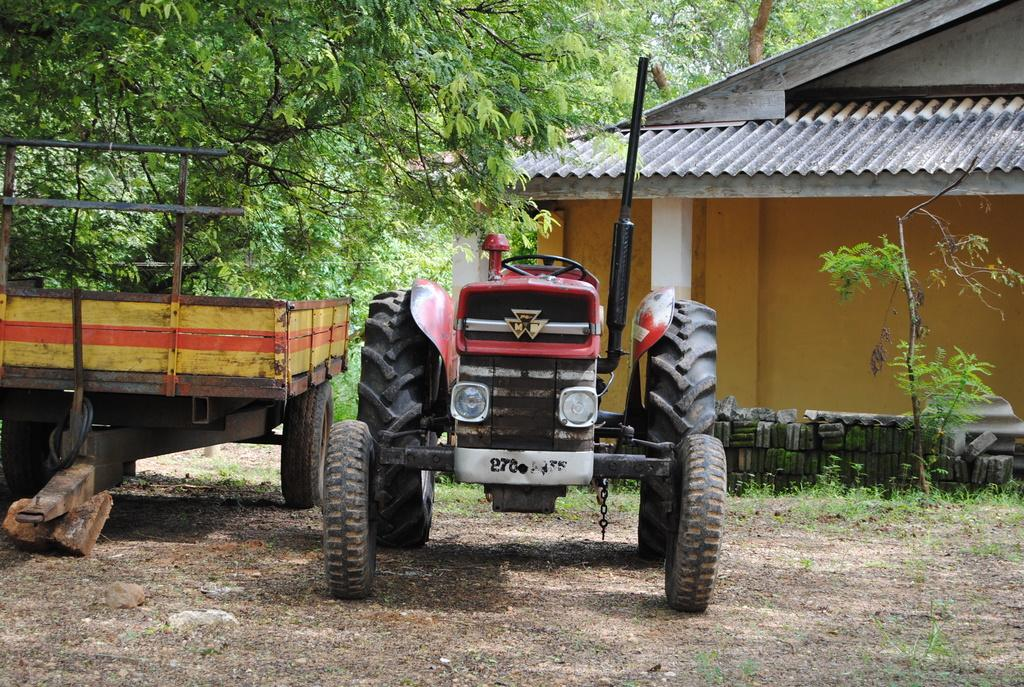What is the main subject in the foreground of the image? There is a vehicle in the foreground of the image. What can be seen in the background of the image? There are trees and a house in the background of the image. What type of loaf is being baked in the house in the image? There is no indication of a loaf or any baking activity in the image. 